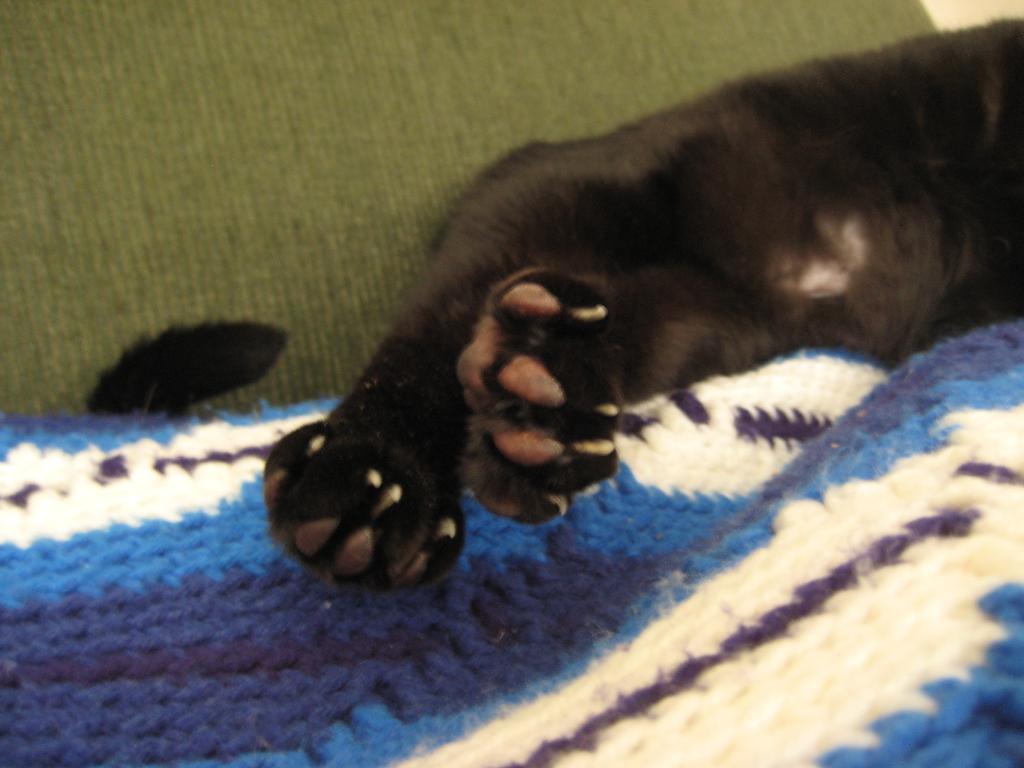Describe this image in one or two sentences. In this image we can see the legs and tail of an animal and a wool cloth. 